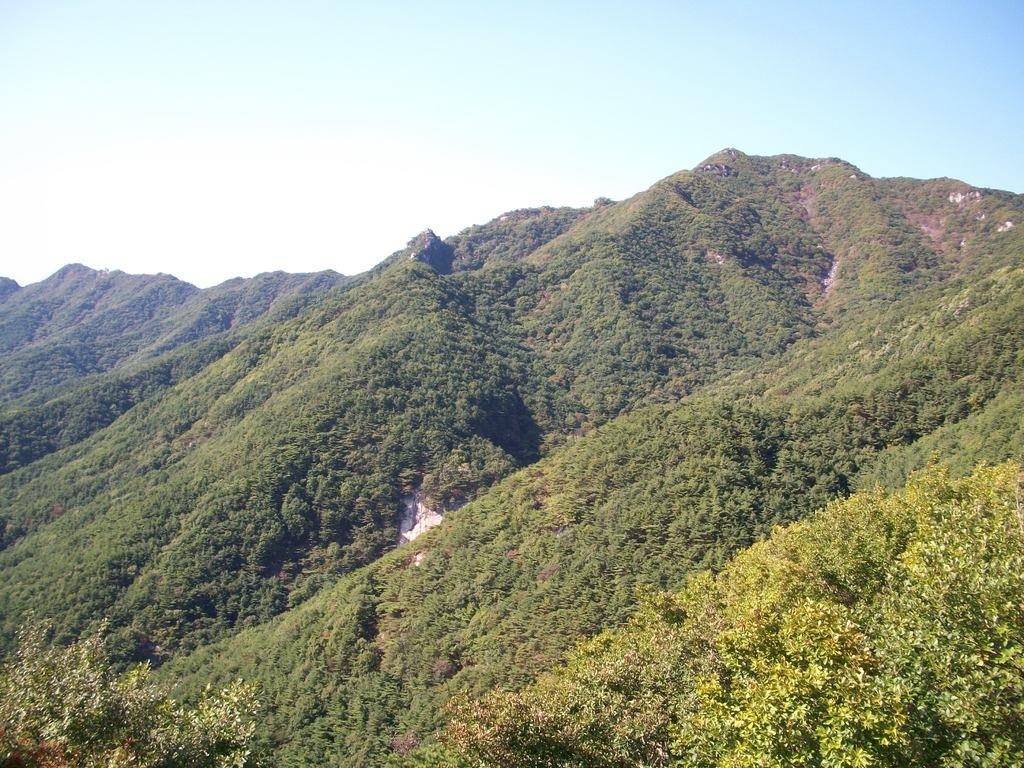What is the main feature in the center of the image? There are mountains and trees in the center of the image. Can you describe the mountains in the image? The mountains are visible in the center of the image. What else can be seen in the center of the image besides the mountains? There are trees in the center of the image. How many apples are hanging from the trees in the image? There is no mention of apples in the image; it features mountains and trees. What type of body is visible in the image? There is no body present in the image; it only features mountains and trees. 